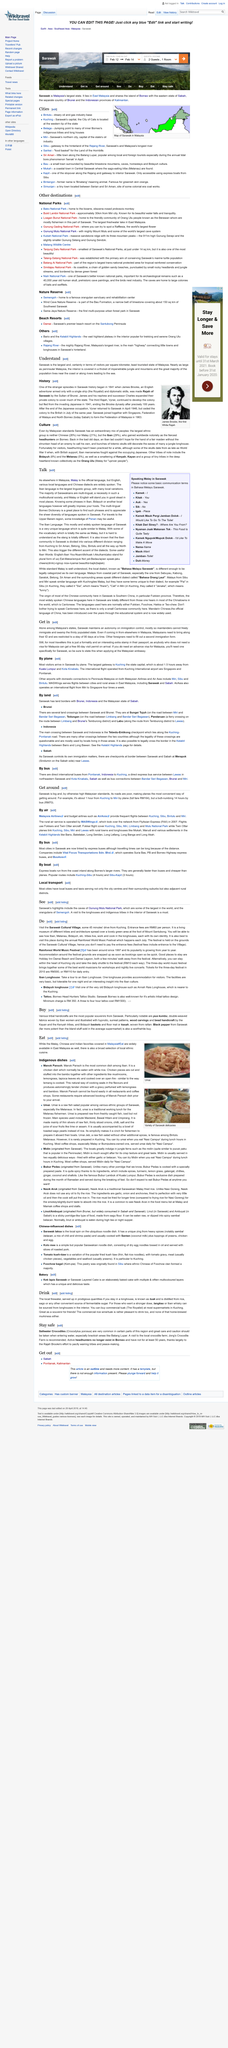Identify some key points in this picture. Sarawak is home to many highlights that offer unique experiences to visitors, including the stunning caves of Gunung Mulu National Park and the opportunity to observe orangutans in their natural habitat at Semengoh. Kuching is the state capital of Sarawak, and it is known for its historic architecture and cultural diversity. Visitors to Sarawak commonly use air transportation, which is the most common mode of transportation in the state. The most commonly taken boat routes include Kuching-Sibu and Sibu-Kapit, which are two of the most popular water transportation routes in the state of Sarawak, Malaysia. The AirAsia flight from Miri to Singapore flies four times a week with a high frequency. 